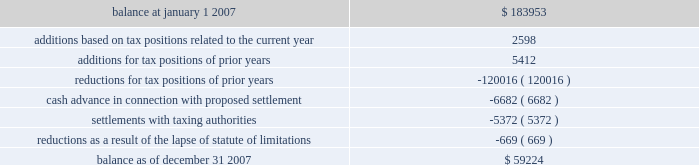American tower corporation and subsidiaries notes to consolidated financial statements 2014 ( continued ) company is currently unable to estimate the impact of the amount of such changes , if any , to previously recorded uncertain tax positions .
A reconciliation of the beginning and ending amount of unrecognized tax benefits for the year ending december 31 , 2007 is as follows ( in thousands ) : .
During the year ended december 31 , 2007 , the company recorded penalties and tax-related interest income of $ 2.5 million and interest income from tax refunds of $ 1.5 million for the year ended december 31 , 2007 .
As of december 31 , 2007 and january 1 , 2007 , the total unrecognized tax benefits included in other long-term liabilities in the consolidated balance sheets was $ 29.6 million and $ 34.3 million , respectively .
As of december 31 , 2007 and january 1 , 2007 , the total amount of accrued income tax-related interest and penalties included in other long-term liabilities in the consolidated balance sheets was $ 30.7 million and $ 33.2 million , respectively .
In the fourth quarter of 2007 , the company entered into a tax amnesty program with the mexican tax authority .
As of december 31 , 2007 , the company had met all of the administrative requirements of the program , which enabled the company to recognize certain tax benefits .
This was confirmed by the mexican tax authority on february 5 , 2008 .
These benefits include a reduction of uncertain tax benefits of $ 5.4 million along with penalties and interest of $ 12.5 million related to 2002 , all of which reduced income tax expense .
In connection with the above program , the company paid $ 6.7 million to the mexican tax authority as a settlement offer for other uncertain tax positions related to 2003 and 2004 .
This offer is currently under review by the mexican tax authority ; the company cannot yet determine the specific timing or the amount of any potential settlement .
During 2007 , the statute of limitations on certain unrecognized tax benefits lapsed , which resulted in a $ 0.7 million decrease in the liability for uncertain tax benefits , all of which reduced the income tax provision .
The company files numerous consolidated and separate income tax returns , including u.s .
Federal and state tax returns and foreign tax returns in mexico and brazil .
As a result of the company 2019s ability to carry forward federal and state net operating losses , the applicable tax years remain open to examination until three years after the applicable loss carryforwards have been used or expired .
However , the company has completed u.s .
Federal income tax examinations for tax years up to and including 2002 .
The company is currently undergoing u.s .
Federal income tax examinations for tax years 2004 and 2005 .
Additionally , it is subject to examinations in various u.s .
State jurisdictions for certain tax years , and is under examination in brazil for the 2001 through 2006 tax years and mexico for the 2002 tax year .
Sfas no .
109 , 201caccounting for income taxes , 201d requires that companies record a valuation allowance when it is 201cmore likely than not that some portion or all of the deferred tax assets will not be realized . 201d at december 31 , 2007 , the company has provided a valuation allowance of approximately $ 88.2 million , including approximately .
What is the net change in the balance of unrecognized tax benefits during 2007? 
Computations: (59224 - 183953)
Answer: -124729.0. 